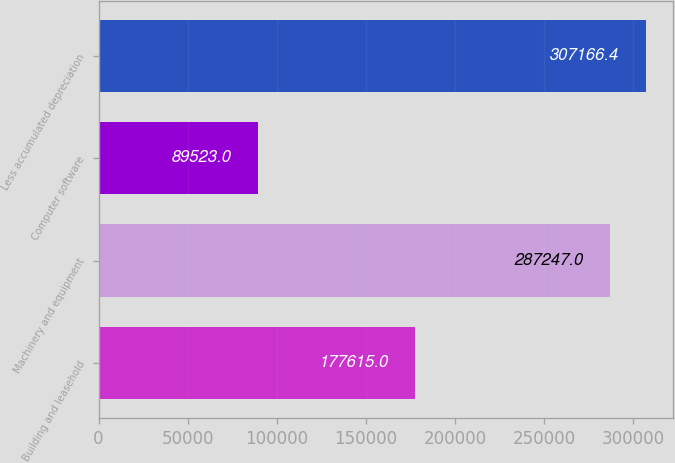<chart> <loc_0><loc_0><loc_500><loc_500><bar_chart><fcel>Building and leasehold<fcel>Machinery and equipment<fcel>Computer software<fcel>Less accumulated depreciation<nl><fcel>177615<fcel>287247<fcel>89523<fcel>307166<nl></chart> 